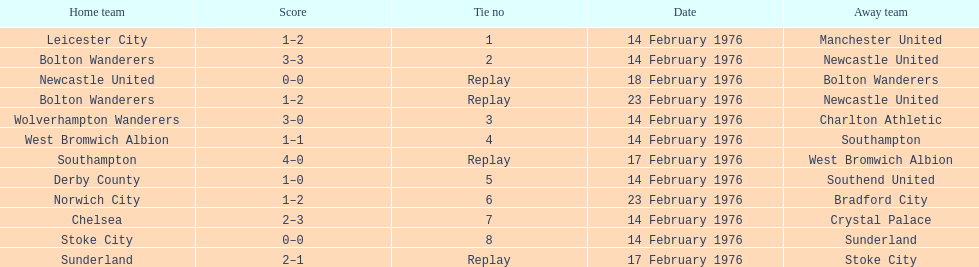What was the number of games played by bolton wanderers and newcastle united until a clear winner emerged in the fifth round proper? 3. 